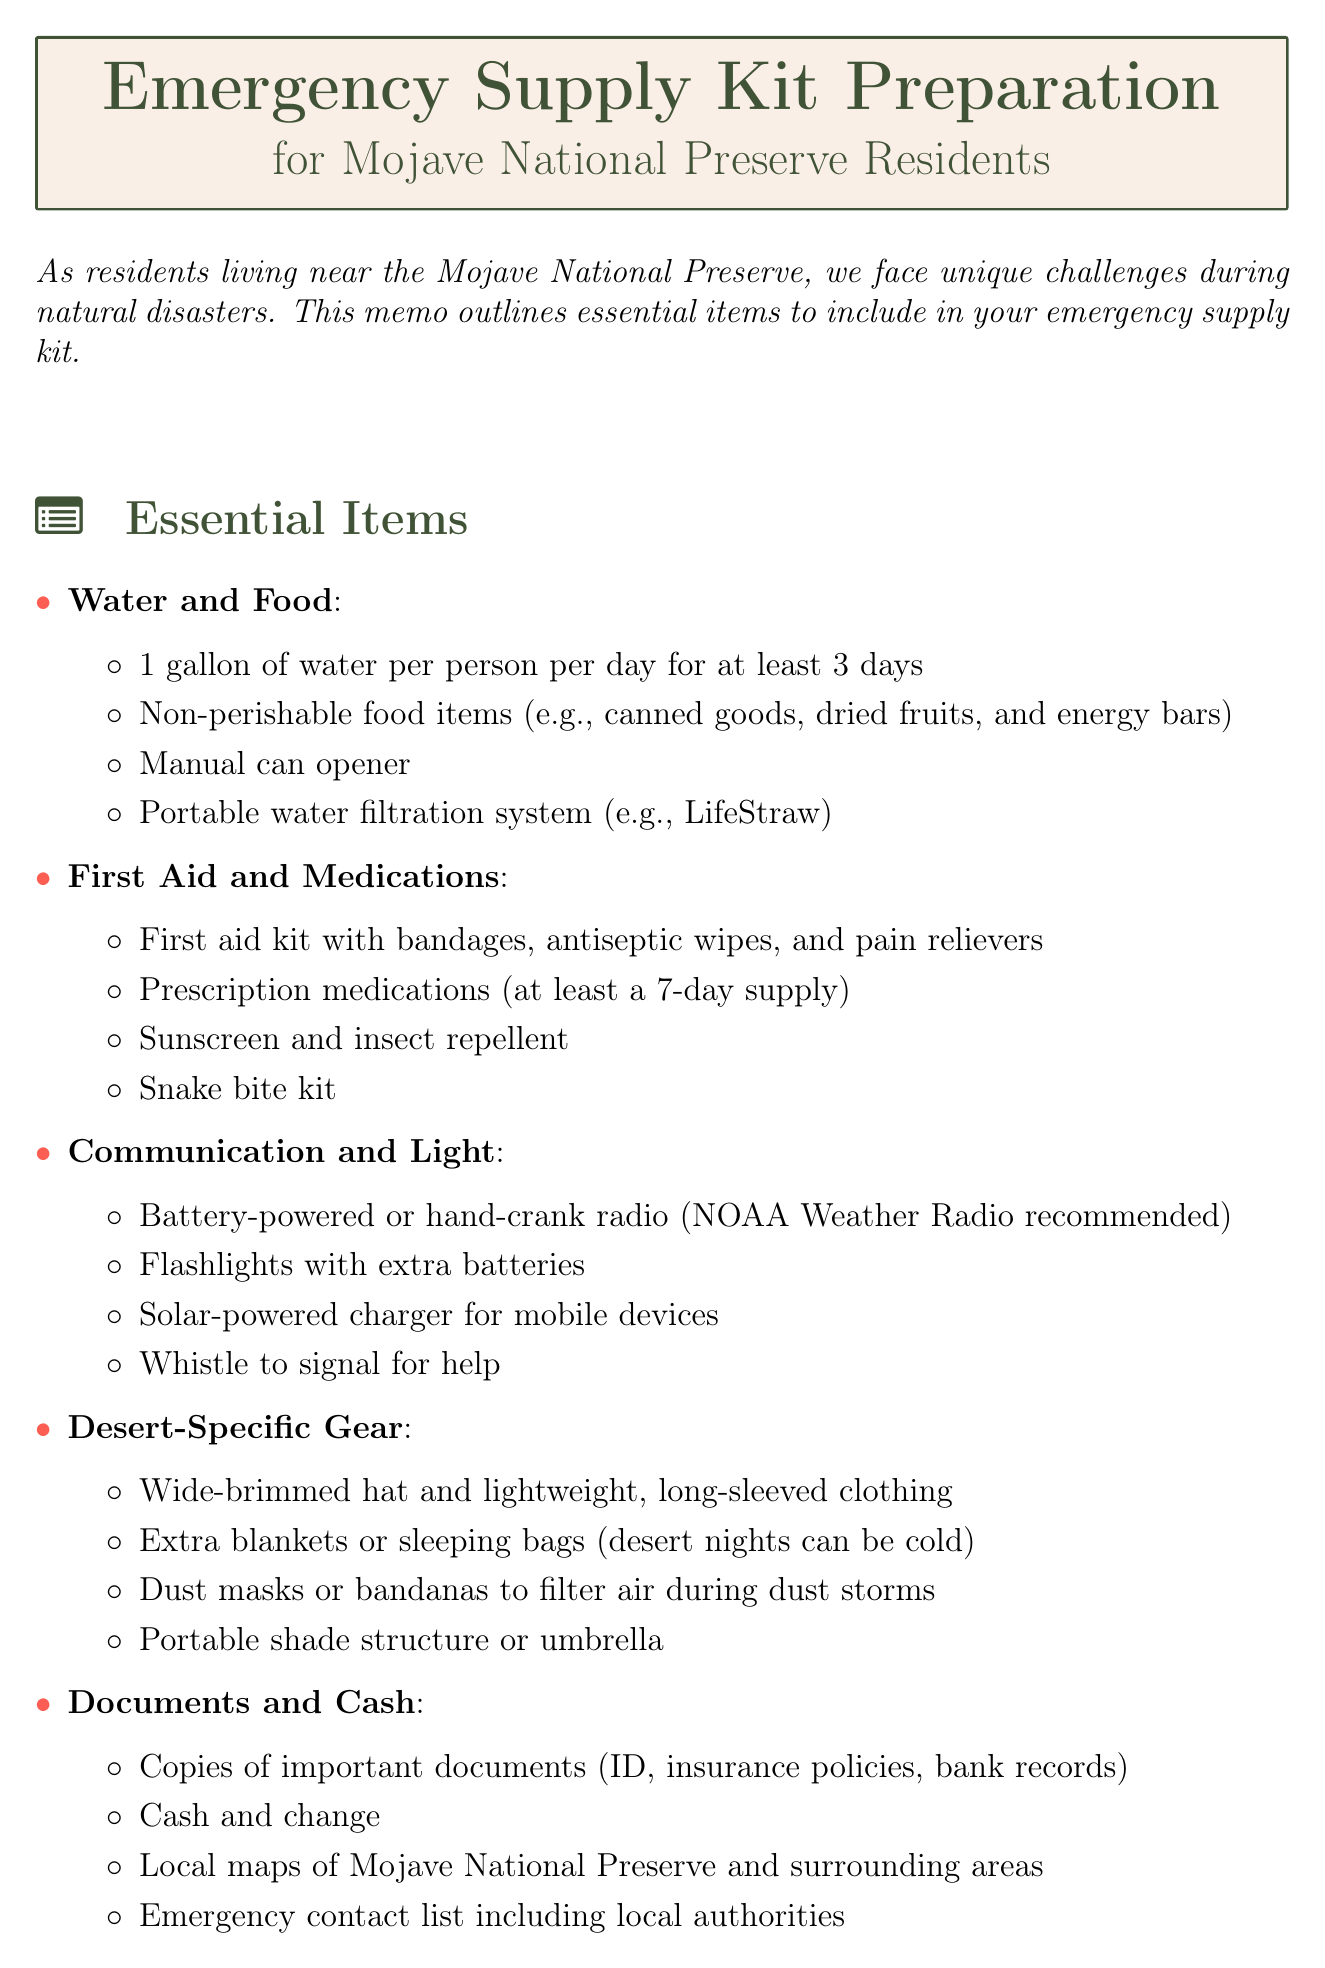What is the title of the memo? The title of the memo is stated at the top of the document.
Answer: Emergency Supply Kit Preparation for Mojave National Preserve Residents How much water should each person have per day? The memo specifies the amount of water needed per person per day under the Water and Food category.
Answer: 1 gallon What is one item listed under Desert-Specific Gear? The document outlines various items in each category, including Desert-Specific Gear.
Answer: Wide-brimmed hat Which radio is recommended in the Communication and Light category? The document suggests a specific type of radio to include in the emergency supply kit.
Answer: NOAA Weather Radio What should be included in the Emergency contact list? The memo mentions what to include in the Emergency contact list under the Documents and Cash category.
Answer: local authorities How many days' worth of prescription medications should be included? The necessary supply of prescription medications is indicated in the First Aid and Medications section.
Answer: at least a 7-day supply What is the nearest major hospital mentioned? The memo provides the name of the nearest major hospital for medical emergencies.
Answer: Barstow Community Hospital Which local resource can be contacted for water-related emergencies? The document lists local resources and their purposes, including those for water-related emergencies.
Answer: Baker Community Services District 